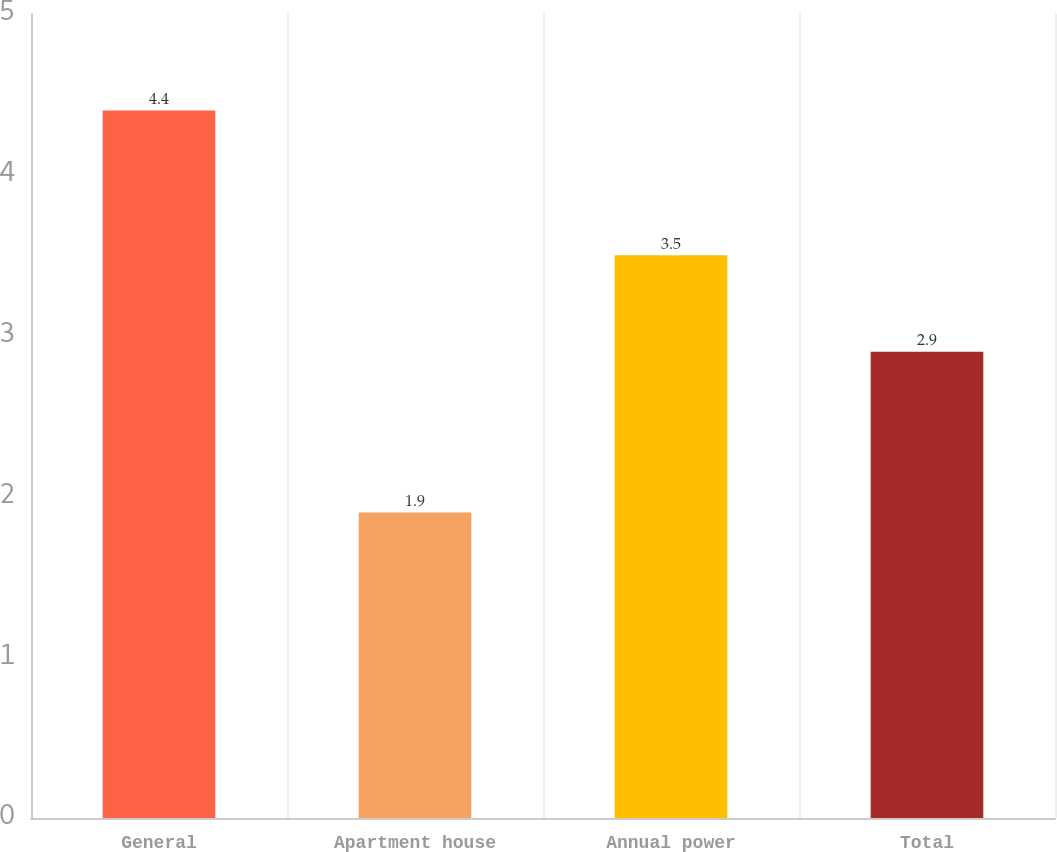<chart> <loc_0><loc_0><loc_500><loc_500><bar_chart><fcel>General<fcel>Apartment house<fcel>Annual power<fcel>Total<nl><fcel>4.4<fcel>1.9<fcel>3.5<fcel>2.9<nl></chart> 